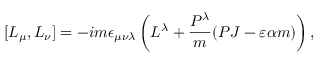<formula> <loc_0><loc_0><loc_500><loc_500>[ L _ { \mu } , L _ { \nu } ] = - i m \epsilon _ { \mu \nu \lambda } \left ( L ^ { \lambda } + \frac { P ^ { \lambda } } { m } ( P J - \varepsilon \alpha m ) \right ) ,</formula> 